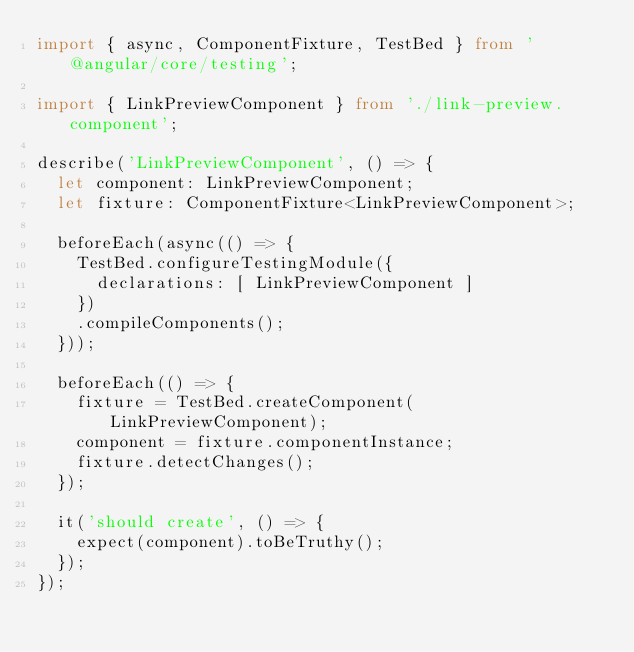Convert code to text. <code><loc_0><loc_0><loc_500><loc_500><_TypeScript_>import { async, ComponentFixture, TestBed } from '@angular/core/testing';

import { LinkPreviewComponent } from './link-preview.component';

describe('LinkPreviewComponent', () => {
  let component: LinkPreviewComponent;
  let fixture: ComponentFixture<LinkPreviewComponent>;

  beforeEach(async(() => {
    TestBed.configureTestingModule({
      declarations: [ LinkPreviewComponent ]
    })
    .compileComponents();
  }));

  beforeEach(() => {
    fixture = TestBed.createComponent(LinkPreviewComponent);
    component = fixture.componentInstance;
    fixture.detectChanges();
  });

  it('should create', () => {
    expect(component).toBeTruthy();
  });
});
</code> 